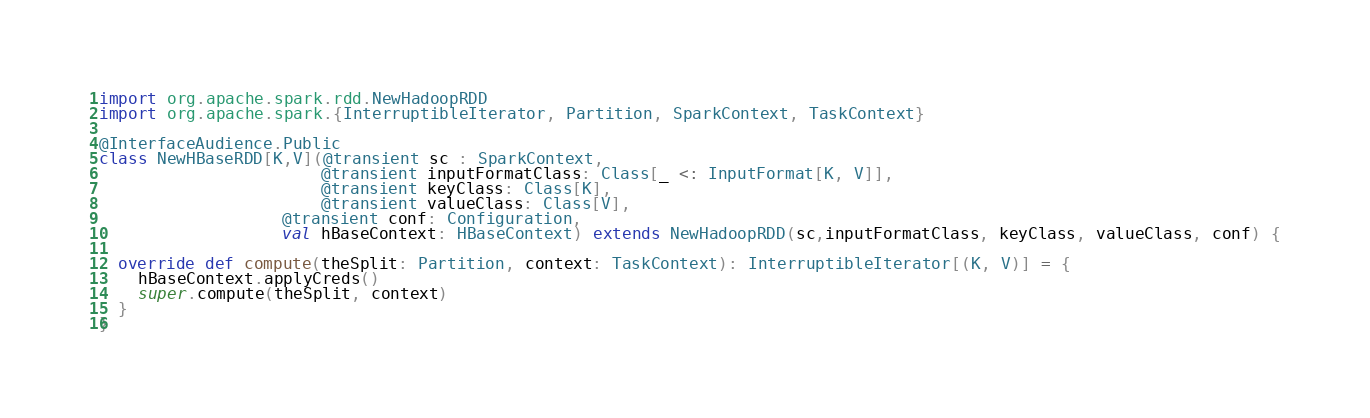Convert code to text. <code><loc_0><loc_0><loc_500><loc_500><_Scala_>import org.apache.spark.rdd.NewHadoopRDD
import org.apache.spark.{InterruptibleIterator, Partition, SparkContext, TaskContext}

@InterfaceAudience.Public
class NewHBaseRDD[K,V](@transient sc : SparkContext,
                       @transient inputFormatClass: Class[_ <: InputFormat[K, V]],
                       @transient keyClass: Class[K],
                       @transient valueClass: Class[V],
                   @transient conf: Configuration,
                   val hBaseContext: HBaseContext) extends NewHadoopRDD(sc,inputFormatClass, keyClass, valueClass, conf) {

  override def compute(theSplit: Partition, context: TaskContext): InterruptibleIterator[(K, V)] = {
    hBaseContext.applyCreds()
    super.compute(theSplit, context)
  }
}
</code> 